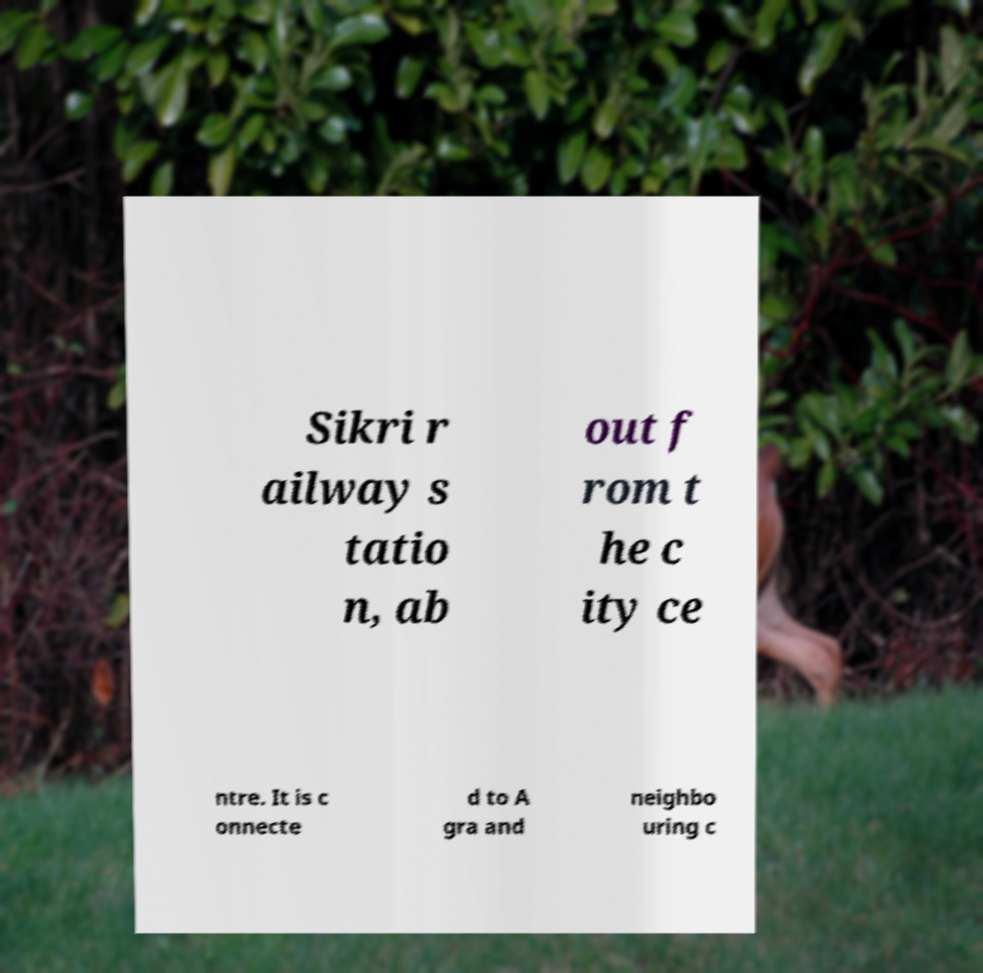Can you read and provide the text displayed in the image?This photo seems to have some interesting text. Can you extract and type it out for me? Sikri r ailway s tatio n, ab out f rom t he c ity ce ntre. It is c onnecte d to A gra and neighbo uring c 